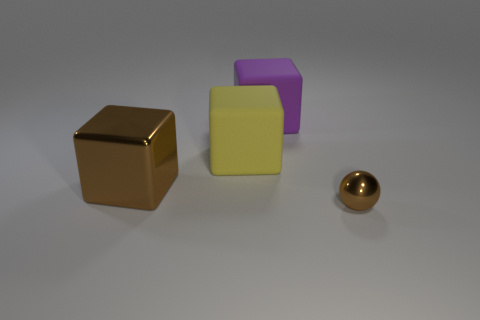Is the ball the same color as the shiny cube?
Give a very brief answer. Yes. Are there any other things that are the same shape as the tiny brown object?
Your answer should be compact. No. Is the color of the metal thing that is to the right of the big brown cube the same as the metal thing that is left of the purple object?
Offer a very short reply. Yes. Is the number of things that are behind the shiny ball greater than the number of big purple rubber cubes?
Offer a very short reply. Yes. How many other objects are there of the same size as the purple thing?
Provide a short and direct response. 2. What number of large blocks are both behind the metal block and in front of the purple rubber thing?
Ensure brevity in your answer.  1. Does the brown thing to the left of the purple thing have the same material as the sphere?
Provide a short and direct response. Yes. What is the shape of the brown object on the left side of the object in front of the metal object that is behind the tiny brown shiny sphere?
Provide a short and direct response. Cube. Are there an equal number of large purple rubber blocks that are to the left of the big purple rubber cube and brown objects that are in front of the big brown block?
Give a very brief answer. No. What color is the shiny block that is the same size as the yellow matte thing?
Keep it short and to the point. Brown. 